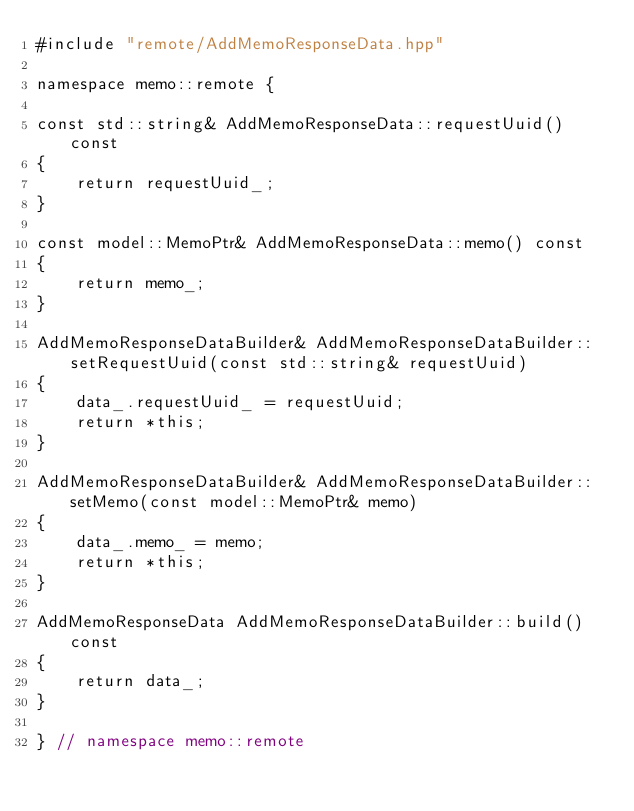Convert code to text. <code><loc_0><loc_0><loc_500><loc_500><_C++_>#include "remote/AddMemoResponseData.hpp"

namespace memo::remote {

const std::string& AddMemoResponseData::requestUuid() const
{
    return requestUuid_;
}

const model::MemoPtr& AddMemoResponseData::memo() const
{
    return memo_;
}

AddMemoResponseDataBuilder& AddMemoResponseDataBuilder::setRequestUuid(const std::string& requestUuid)
{
    data_.requestUuid_ = requestUuid;
    return *this;
}

AddMemoResponseDataBuilder& AddMemoResponseDataBuilder::setMemo(const model::MemoPtr& memo)
{
    data_.memo_ = memo;
    return *this;
}

AddMemoResponseData AddMemoResponseDataBuilder::build() const
{
    return data_;
}

} // namespace memo::remote
</code> 